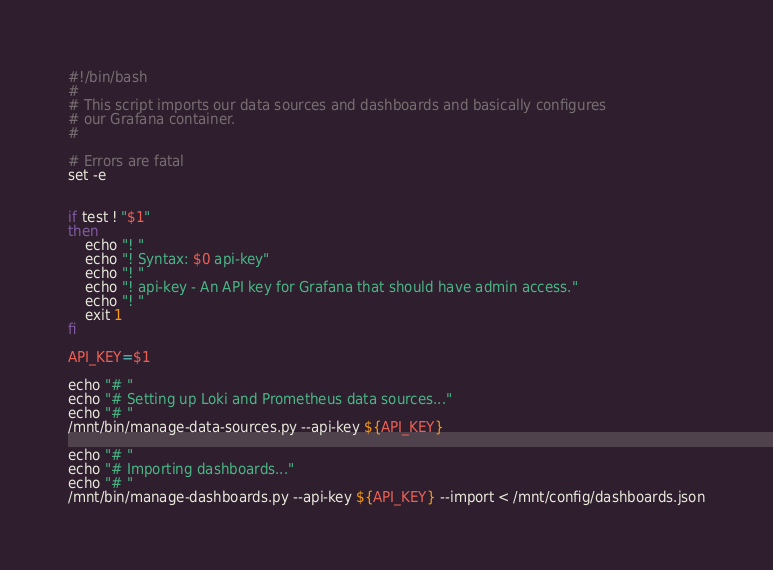<code> <loc_0><loc_0><loc_500><loc_500><_Bash_>#!/bin/bash
#
# This script imports our data sources and dashboards and basically configures
# our Grafana container.
#

# Errors are fatal
set -e


if test ! "$1"
then
	echo "! "
	echo "! Syntax: $0 api-key"
	echo "! "
	echo "! api-key - An API key for Grafana that should have admin access."
	echo "! "
	exit 1
fi

API_KEY=$1

echo "# "
echo "# Setting up Loki and Prometheus data sources..."
echo "# "
/mnt/bin/manage-data-sources.py --api-key ${API_KEY}

echo "# "
echo "# Importing dashboards..."
echo "# "
/mnt/bin/manage-dashboards.py --api-key ${API_KEY} --import < /mnt/config/dashboards.json


</code> 